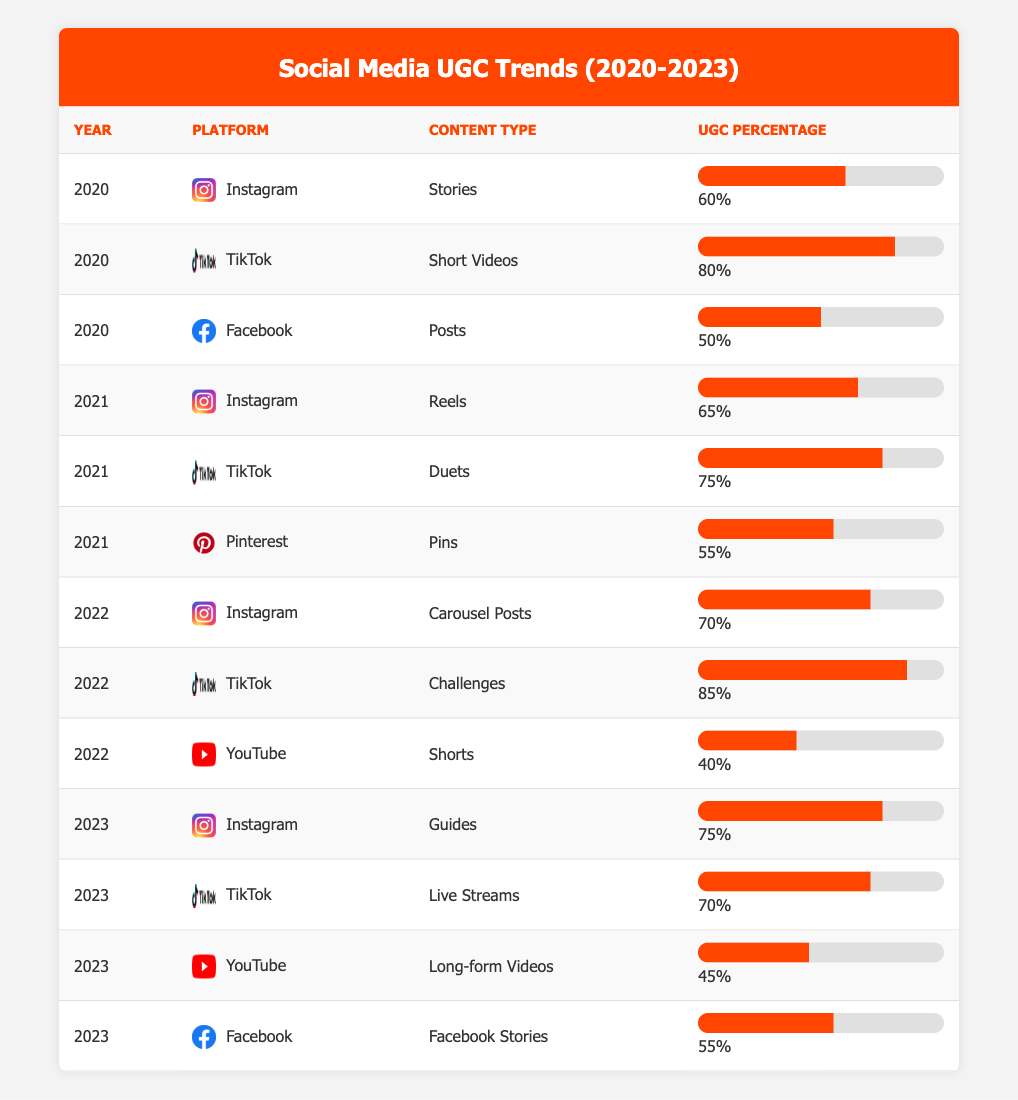What was the user-generated content percentage for TikTok in 2022? In 2022, TikTok's content type was "Challenges," with a user-generated content percentage of 85%. This information is located within the relevant row for the year 2022 and the platform TikTok.
Answer: 85% Which platform had the highest percentage of user-generated content in 2021? In 2021, TikTok had a user-generated content percentage of 75% for the content type "Duets," which was the highest among the listed platforms for that year. No other platform reached or exceeded that percentage.
Answer: TikTok How much did Instagram's user-generated content percentage increase from 2020 to 2023? In 2020, Instagram's user-generated content percentage for "Stories" was 60%, and by 2023 for "Guides," it was 75%. The increase is calculated as 75% - 60% = 15%.
Answer: 15% Is the user-generated content percentage for Facebook's "Posts" in 2020 greater than its "Stories" in 2023? The percentage for Facebook's "Posts" in 2020 was 50%, while "Facebook Stories" in 2023 had a percentage of 55%. Since 55% is greater than 50%, the statement is true.
Answer: Yes What is the average user-generated content percentage for all TikTok content types from 2020 to 2023? To find the average, sum TikTok percentages: 80% (2020) + 75% (2021) + 85% (2022) + 70% (2023) = 310%. Then, divide by the number of data points (4): 310% / 4 = 77.5%.
Answer: 77.5% 